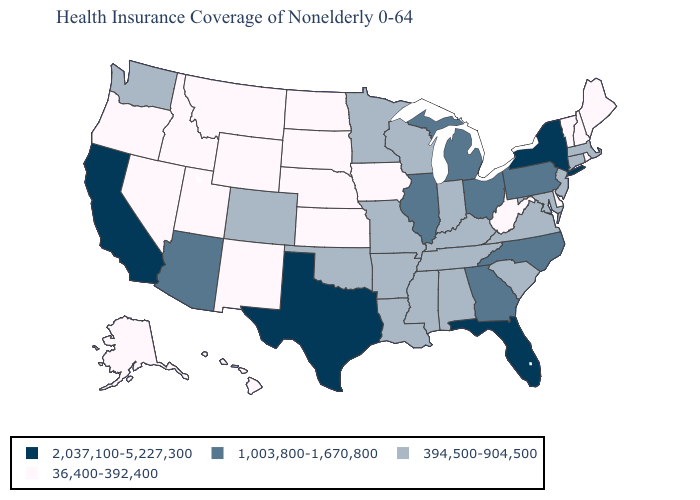What is the value of Minnesota?
Short answer required. 394,500-904,500. Name the states that have a value in the range 1,003,800-1,670,800?
Quick response, please. Arizona, Georgia, Illinois, Michigan, North Carolina, Ohio, Pennsylvania. Which states have the lowest value in the MidWest?
Answer briefly. Iowa, Kansas, Nebraska, North Dakota, South Dakota. Name the states that have a value in the range 1,003,800-1,670,800?
Give a very brief answer. Arizona, Georgia, Illinois, Michigan, North Carolina, Ohio, Pennsylvania. Which states have the highest value in the USA?
Answer briefly. California, Florida, New York, Texas. Name the states that have a value in the range 394,500-904,500?
Concise answer only. Alabama, Arkansas, Colorado, Connecticut, Indiana, Kentucky, Louisiana, Maryland, Massachusetts, Minnesota, Mississippi, Missouri, New Jersey, Oklahoma, South Carolina, Tennessee, Virginia, Washington, Wisconsin. What is the highest value in states that border Connecticut?
Be succinct. 2,037,100-5,227,300. Does the first symbol in the legend represent the smallest category?
Quick response, please. No. Does Hawaii have the same value as Kansas?
Write a very short answer. Yes. Which states have the lowest value in the USA?
Give a very brief answer. Alaska, Delaware, Hawaii, Idaho, Iowa, Kansas, Maine, Montana, Nebraska, Nevada, New Hampshire, New Mexico, North Dakota, Oregon, Rhode Island, South Dakota, Utah, Vermont, West Virginia, Wyoming. Does the first symbol in the legend represent the smallest category?
Write a very short answer. No. Among the states that border Arizona , which have the highest value?
Quick response, please. California. Name the states that have a value in the range 36,400-392,400?
Quick response, please. Alaska, Delaware, Hawaii, Idaho, Iowa, Kansas, Maine, Montana, Nebraska, Nevada, New Hampshire, New Mexico, North Dakota, Oregon, Rhode Island, South Dakota, Utah, Vermont, West Virginia, Wyoming. What is the value of Missouri?
Short answer required. 394,500-904,500. 